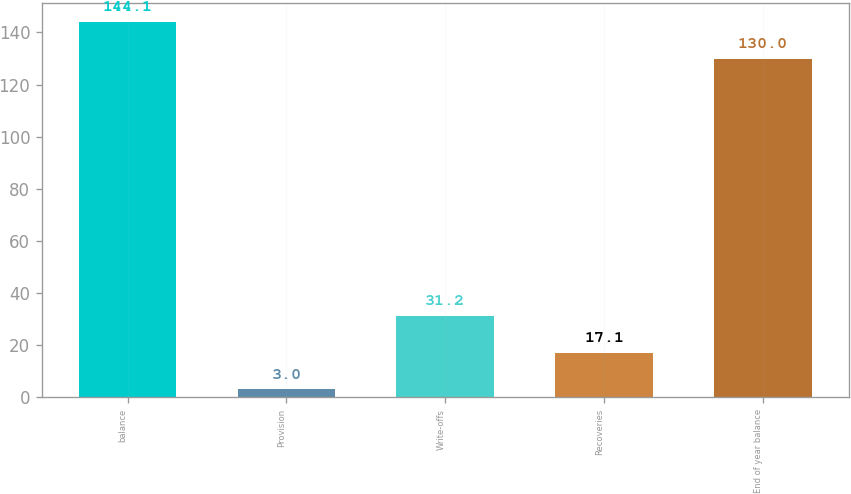Convert chart to OTSL. <chart><loc_0><loc_0><loc_500><loc_500><bar_chart><fcel>balance<fcel>Provision<fcel>Write-offs<fcel>Recoveries<fcel>End of year balance<nl><fcel>144.1<fcel>3<fcel>31.2<fcel>17.1<fcel>130<nl></chart> 